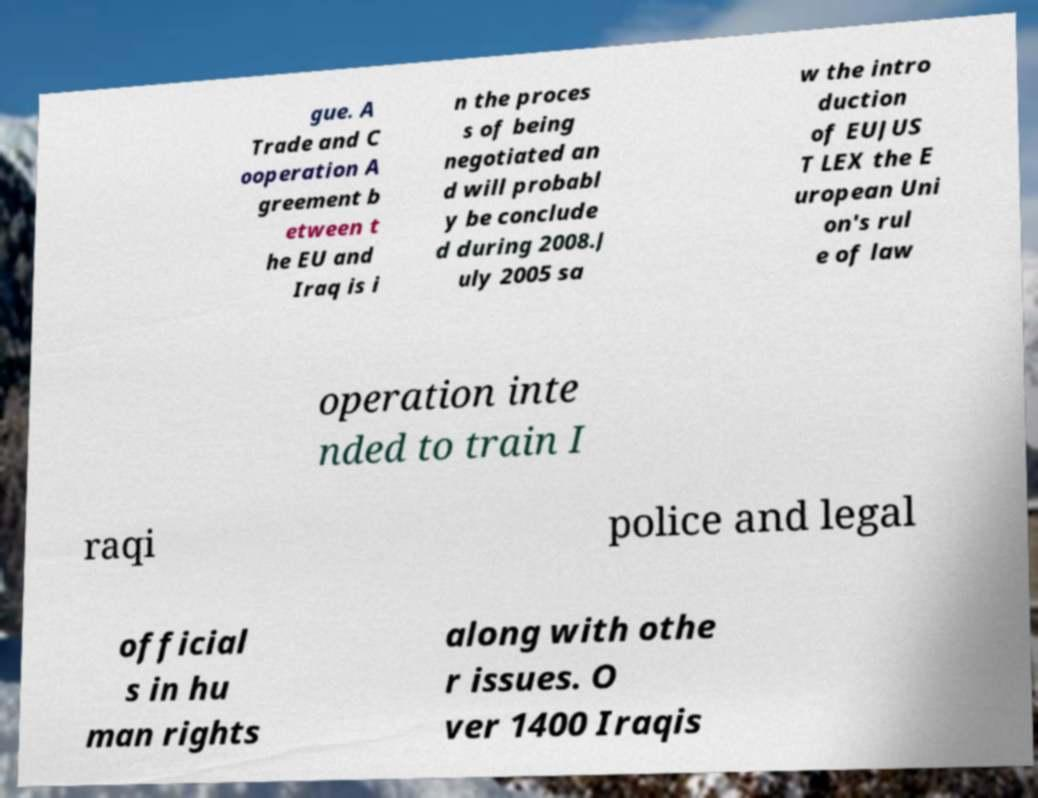Please identify and transcribe the text found in this image. gue. A Trade and C ooperation A greement b etween t he EU and Iraq is i n the proces s of being negotiated an d will probabl y be conclude d during 2008.J uly 2005 sa w the intro duction of EUJUS T LEX the E uropean Uni on's rul e of law operation inte nded to train I raqi police and legal official s in hu man rights along with othe r issues. O ver 1400 Iraqis 